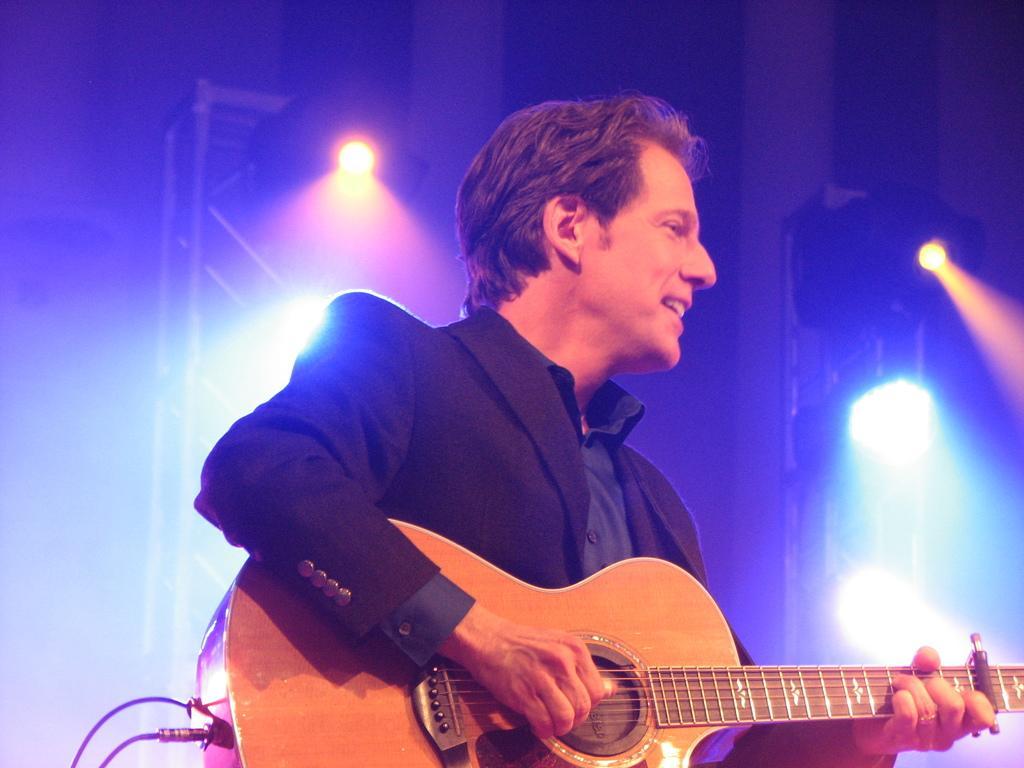Can you describe this image briefly? As we can see in the image there are lights and a man holding guitar. 